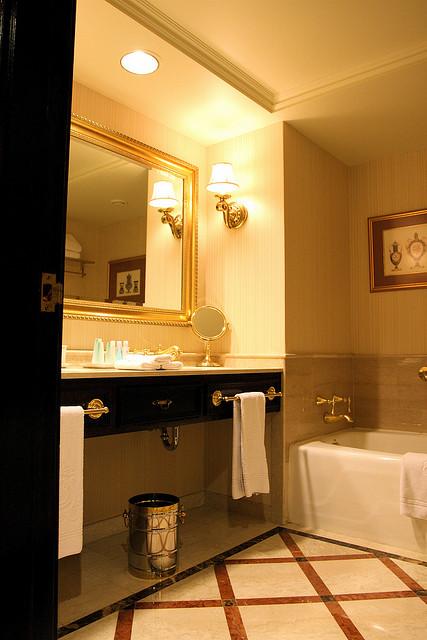How many sinks are in the bathroom?
Short answer required. 2. What shape do the brown tiles make on the floor?
Short answer required. Diamonds. What room is this?
Be succinct. Bathroom. Where is the mirror?
Quick response, please. Bathroom. What does the sign say on the back wall?
Concise answer only. Nothing. What is on the wall above the bathtub?
Concise answer only. Picture. How many pictures are on the walls?
Write a very short answer. 1. Is this a public restroom?
Write a very short answer. No. What color is the waste basket?
Answer briefly. Silver. 